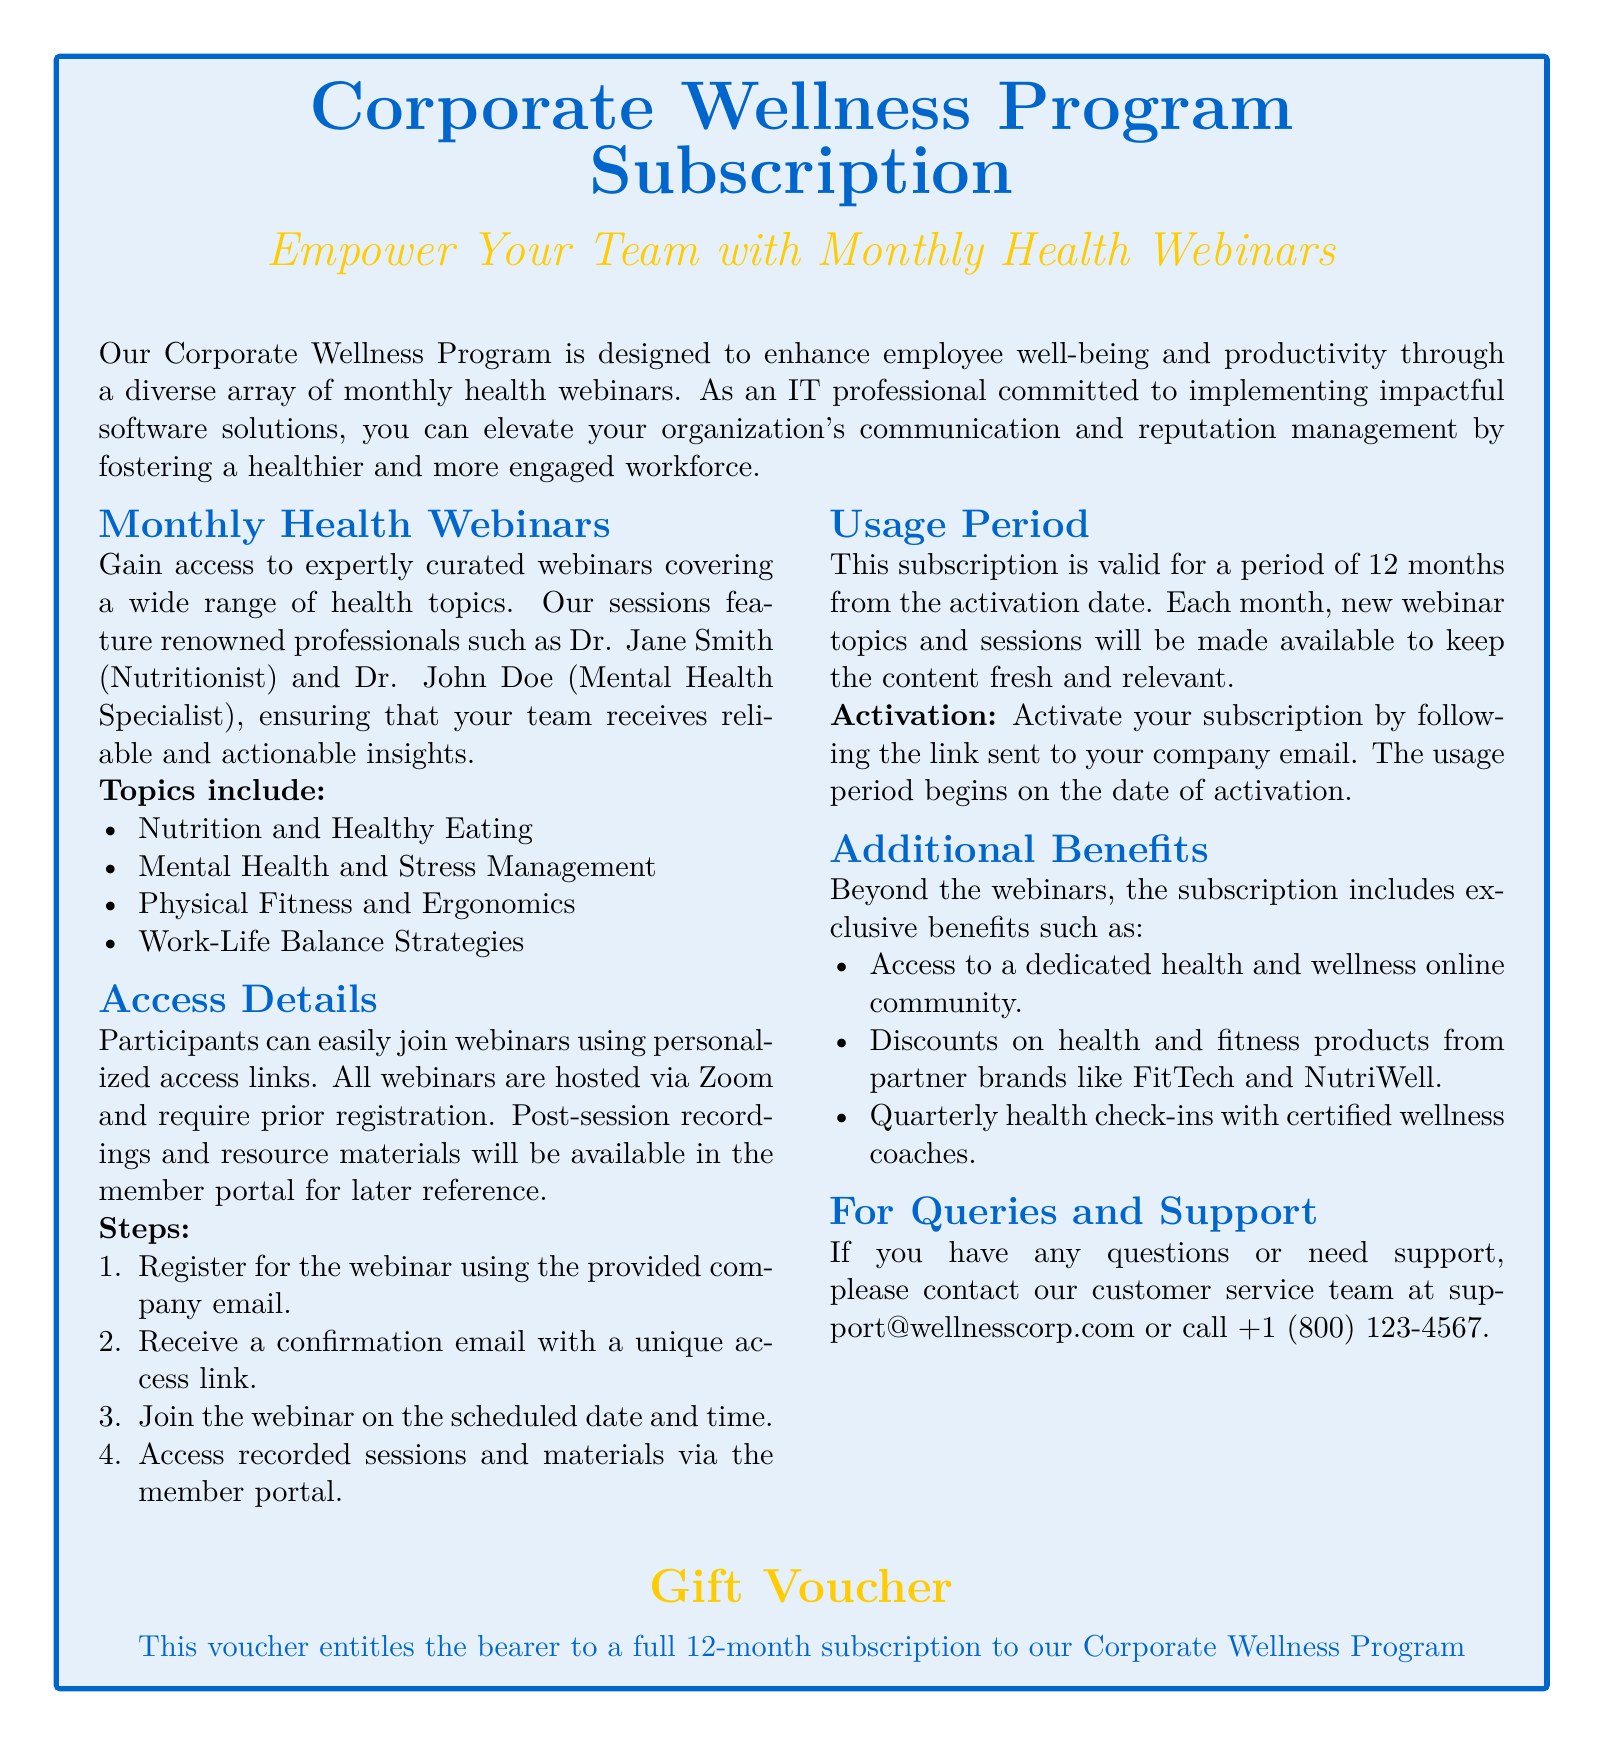What is the duration of the subscription? The subscription is valid for a period of 12 months from the activation date.
Answer: 12 months Who are the featured professionals in the webinars? The document mentions renowned professionals such as Dr. Jane Smith and Dr. John Doe as featured in the webinars.
Answer: Dr. Jane Smith and Dr. John Doe What is required to join the webinars? Participants need to register for the webinar using their company email and will receive a unique access link.
Answer: Confirmation email with a unique access link What kind of community access is included? The subscription includes access to a dedicated health and wellness online community.
Answer: Health and wellness online community When does the usage period begin? The usage period begins on the date of activation, which follows the link sent to the company email.
Answer: Date of activation What type of additional benefits are offered with the subscription? The subscription includes exclusive benefits like discounts on health and fitness products and quarterly health check-ins.
Answer: Discounts on health and fitness products How can a user contact for support? Users can contact customer service via the email or phone number provided in the document.
Answer: support@wellnesscorp.com or +1 (800) 123-4567 What are the monthly health webinar topics? The document lists topics such as Nutrition and Healthy Eating and Mental Health and Stress Management addressing different health aspects.
Answer: Nutrition and Healthy Eating, Mental Health and Stress Management 